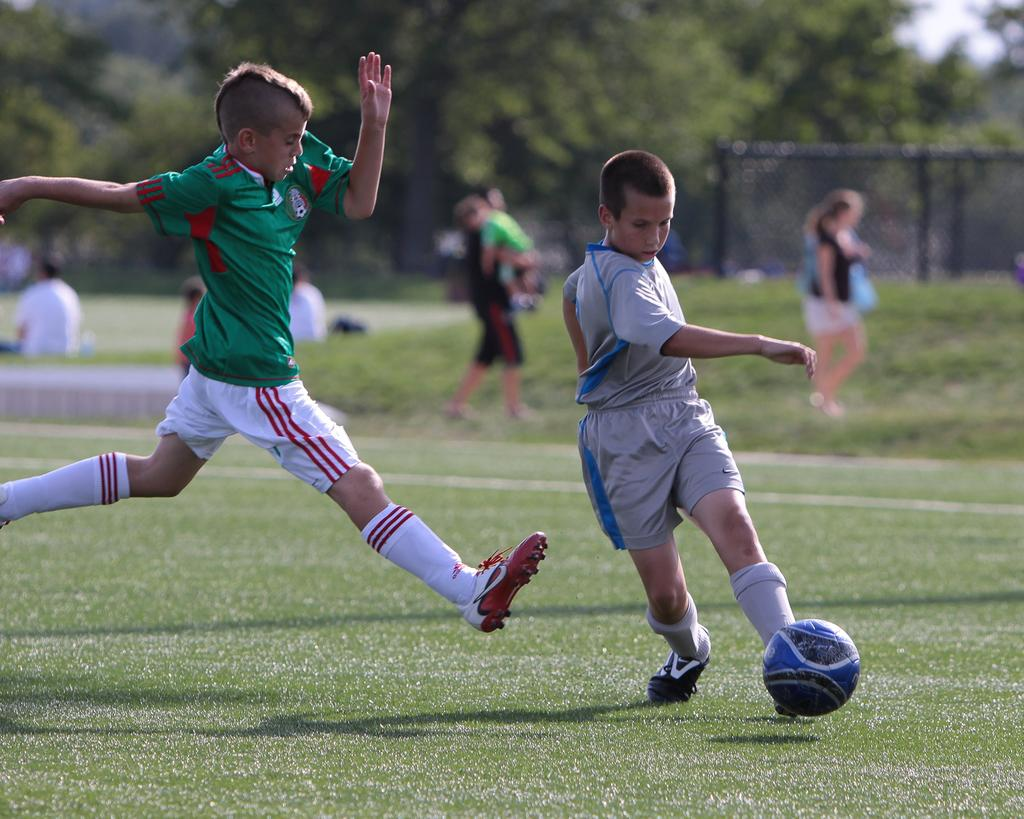How many kids are in the image? There are two kids in the image. What are the kids doing in the image? The kids are running in the ground and playing with a ball. What can be seen in the background of the image? There are people walking and trees present in the background of the image. What type of can is visible in the image? There is no can present in the image. Is there a bridge in the image? No, there is no bridge in the image. 